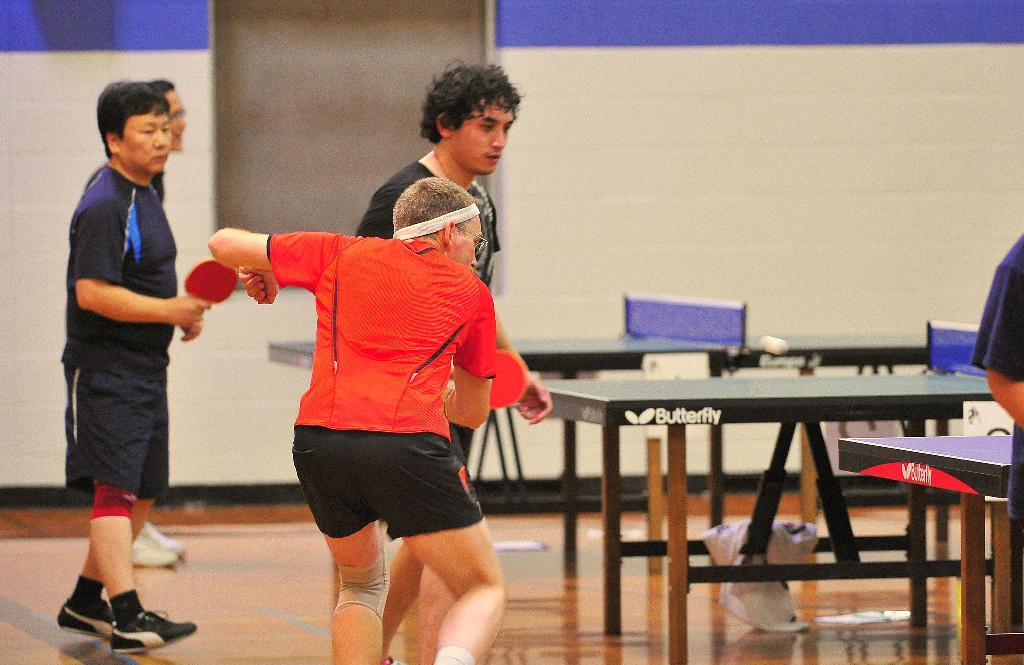How many people are in the image? There is a group of people in the image. Can you describe the clothing of one of the individuals? One person is wearing a red t-shirt. What is the person in the red t-shirt holding? The person in the red t-shirt is holding a tennis bat. What type of furniture is present in the image? There are tables on the floor in the image. Where is the vase placed in the image? There is no vase present in the image. What type of ring is the person in the red t-shirt wearing? The person in the red t-shirt is not wearing a ring in the image. 